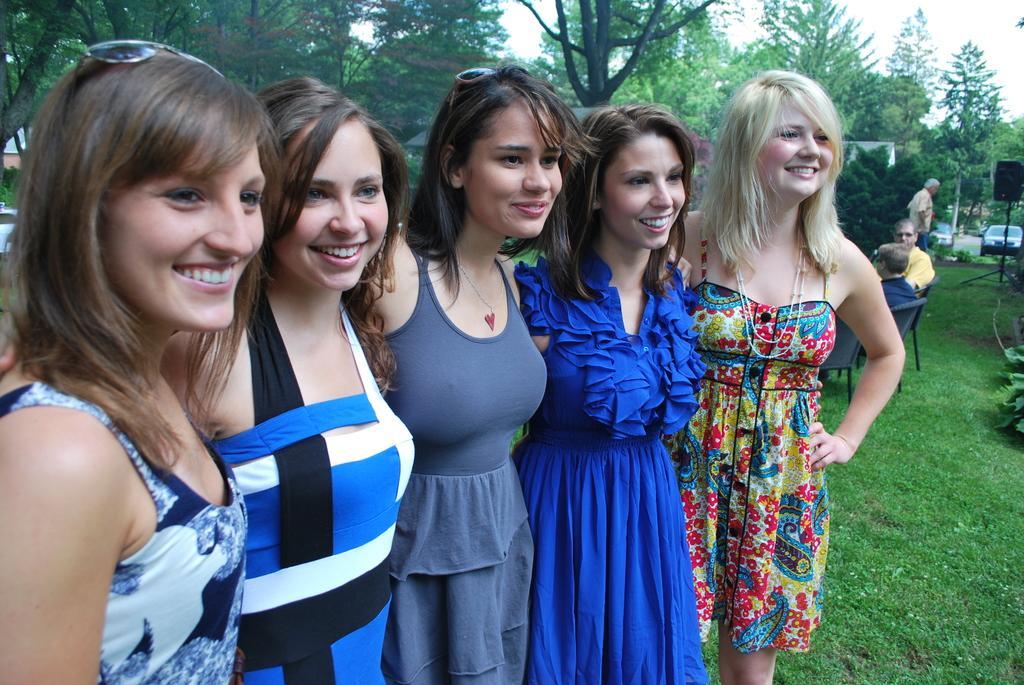How would you summarize this image in a sentence or two? In this picture we can observe five women standing. All of them were smiling. Some of them were wearing spectacles on their heads. On the right side there are two men sitting in the chairs. We can observe some grass on the ground. In the background there are trees and a sky. 